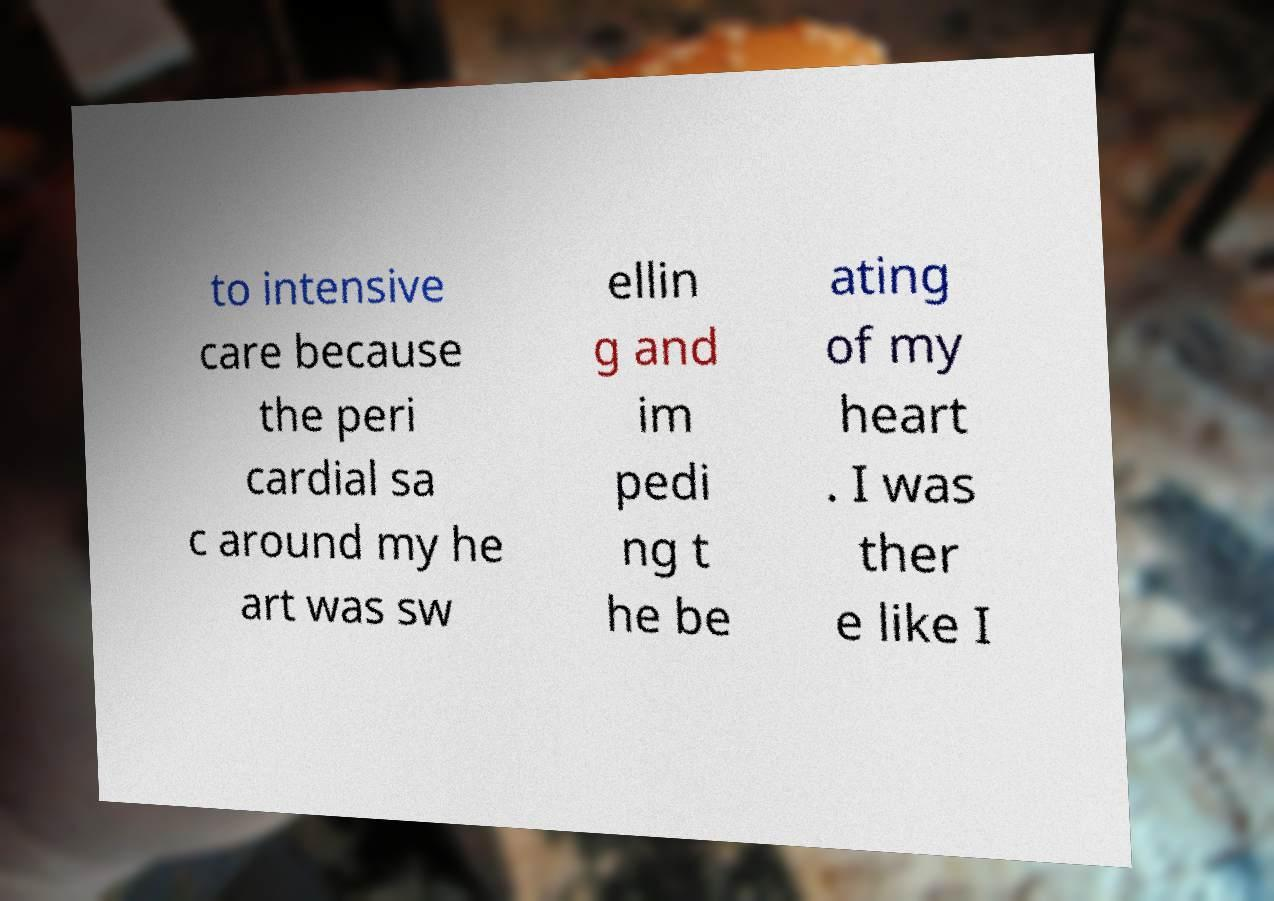Could you assist in decoding the text presented in this image and type it out clearly? to intensive care because the peri cardial sa c around my he art was sw ellin g and im pedi ng t he be ating of my heart . I was ther e like I 